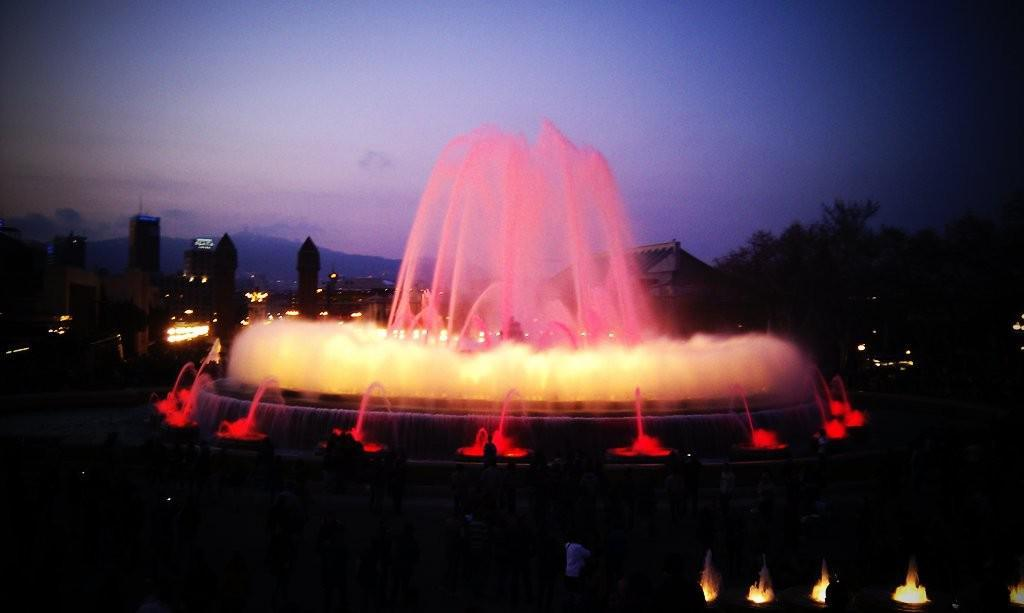What is the main feature in the image? There is a water fountain in the image. What else can be seen in the image besides the water fountain? There are lights, buildings, trees, and the sky visible in the image. Can you describe the lighting in the image? Yes, there are lights in the image. What type of natural elements are present in the image? There are trees in the image. What type of breakfast is being served in the image? There is no breakfast present in the image; it features a water fountain, lights, buildings, trees, and the sky. Why is the school crying in the image? There is no school or crying depicted in the image. 